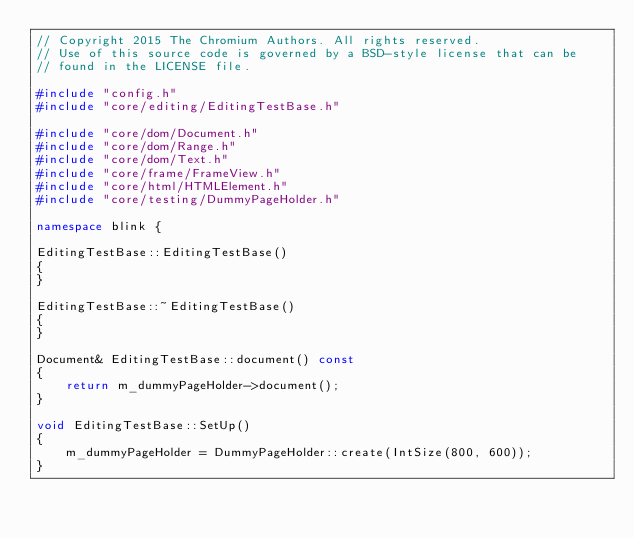Convert code to text. <code><loc_0><loc_0><loc_500><loc_500><_C++_>// Copyright 2015 The Chromium Authors. All rights reserved.
// Use of this source code is governed by a BSD-style license that can be
// found in the LICENSE file.

#include "config.h"
#include "core/editing/EditingTestBase.h"

#include "core/dom/Document.h"
#include "core/dom/Range.h"
#include "core/dom/Text.h"
#include "core/frame/FrameView.h"
#include "core/html/HTMLElement.h"
#include "core/testing/DummyPageHolder.h"

namespace blink {

EditingTestBase::EditingTestBase()
{
}

EditingTestBase::~EditingTestBase()
{
}

Document& EditingTestBase::document() const
{
    return m_dummyPageHolder->document();
}

void EditingTestBase::SetUp()
{
    m_dummyPageHolder = DummyPageHolder::create(IntSize(800, 600));
}
</code> 